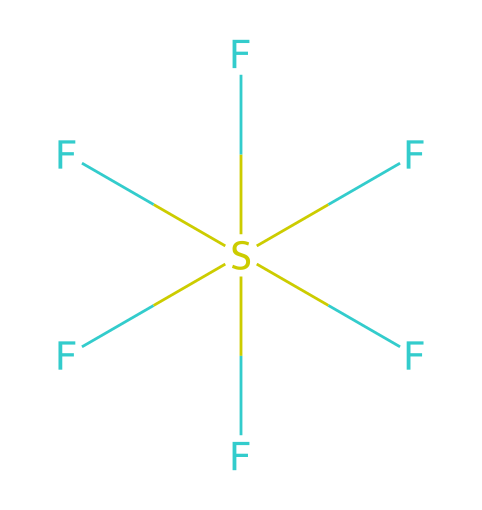How many fluorine atoms are in this compound? The structure shows six fluorine atoms connected to a sulfur atom. Each "F" in the SMILES represents a fluorine atom bound to the central sulfur atom.
Answer: six What is the central atom in this chemical structure? In the provided SMILES representation, "S" denotes sulfur as the central atom surrounded by fluorine atoms.
Answer: sulfur What is the molecular geometry of sulfur hexafluoride? Considering the arrangement of six fluorine atoms around the sulfur atom, the geometry is octahedral, which is characteristic of SF6 due to its symmetric distribution.
Answer: octahedral What type of compound is sulfur hexafluoride? This compound is classified as a sulfur fluorohalide due to its sulfur atom and fluorine atoms, both non-metals.
Answer: fluorohalide Why is sulfur hexafluoride used in electrical equipment? Sulfur hexafluoride possesses excellent insulating properties, which makes it ideal for high-voltage electrical applications, providing high dielectric strength and stability.
Answer: insulating properties Is sulfur hexafluoride a greenhouse gas? Yes, sulfur hexafluoride is considered a potent greenhouse gas, contributing to global warming, due to its high global warming potential.
Answer: yes 